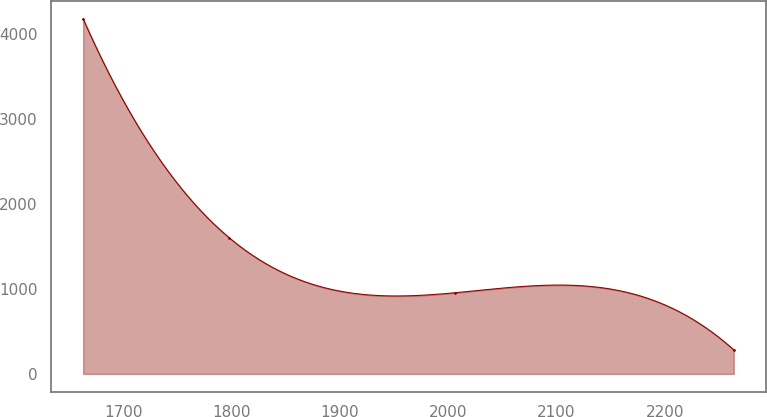Convert chart to OTSL. <chart><loc_0><loc_0><loc_500><loc_500><line_chart><ecel><fcel>Unnamed: 1<nl><fcel>1662.85<fcel>4181.4<nl><fcel>1797.87<fcel>1601.87<nl><fcel>2006.43<fcel>955.81<nl><fcel>2263.63<fcel>283.13<nl></chart> 